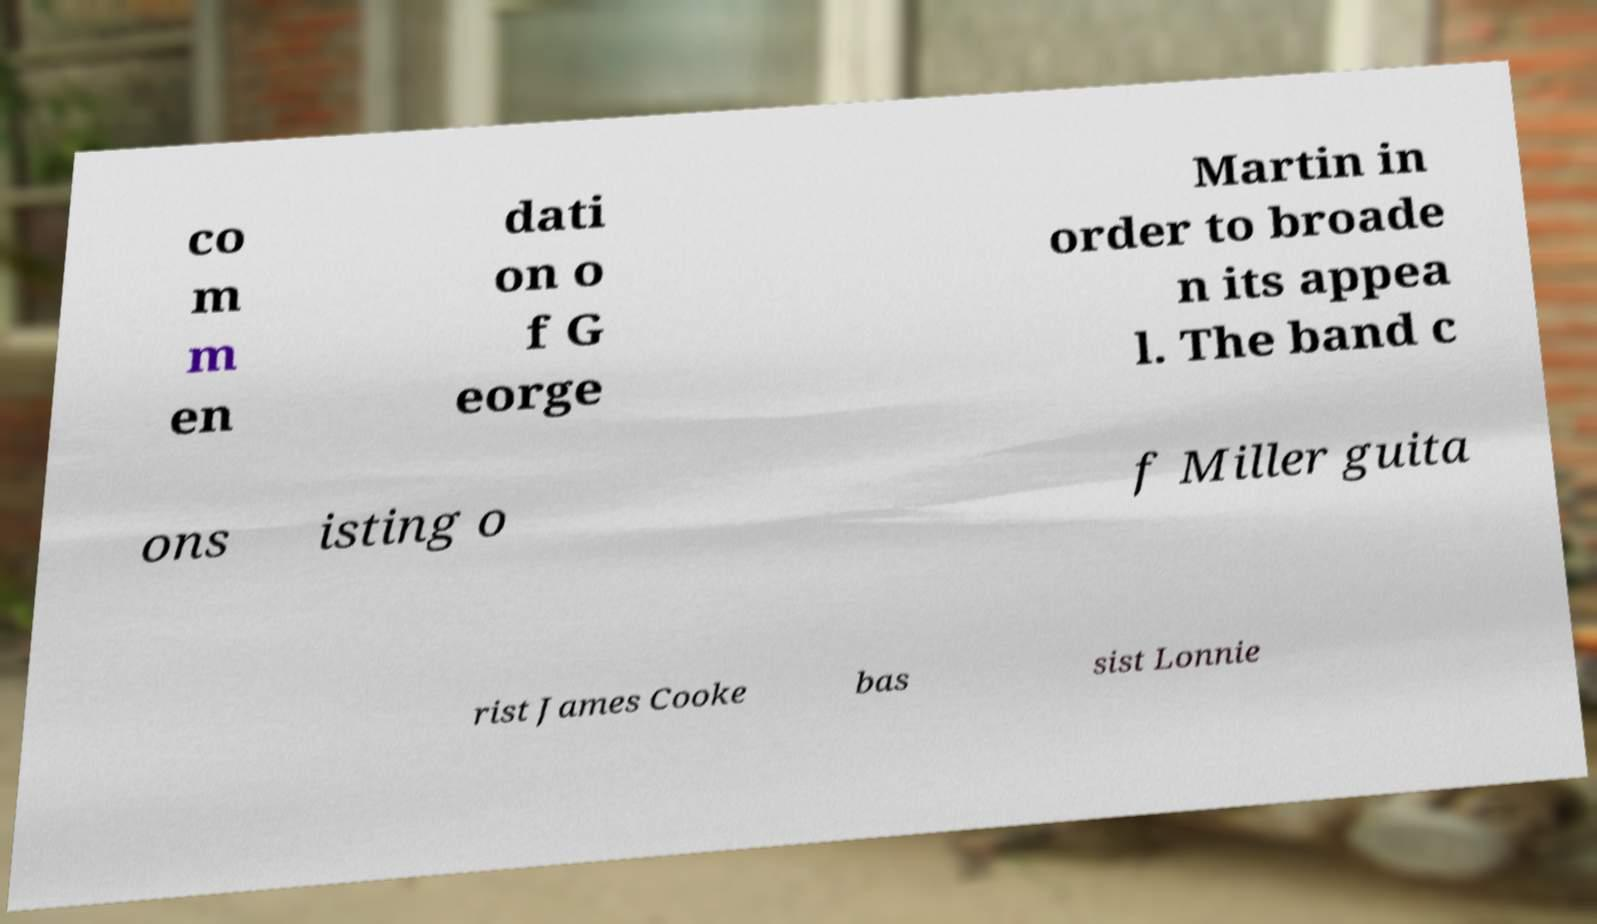Can you accurately transcribe the text from the provided image for me? co m m en dati on o f G eorge Martin in order to broade n its appea l. The band c ons isting o f Miller guita rist James Cooke bas sist Lonnie 